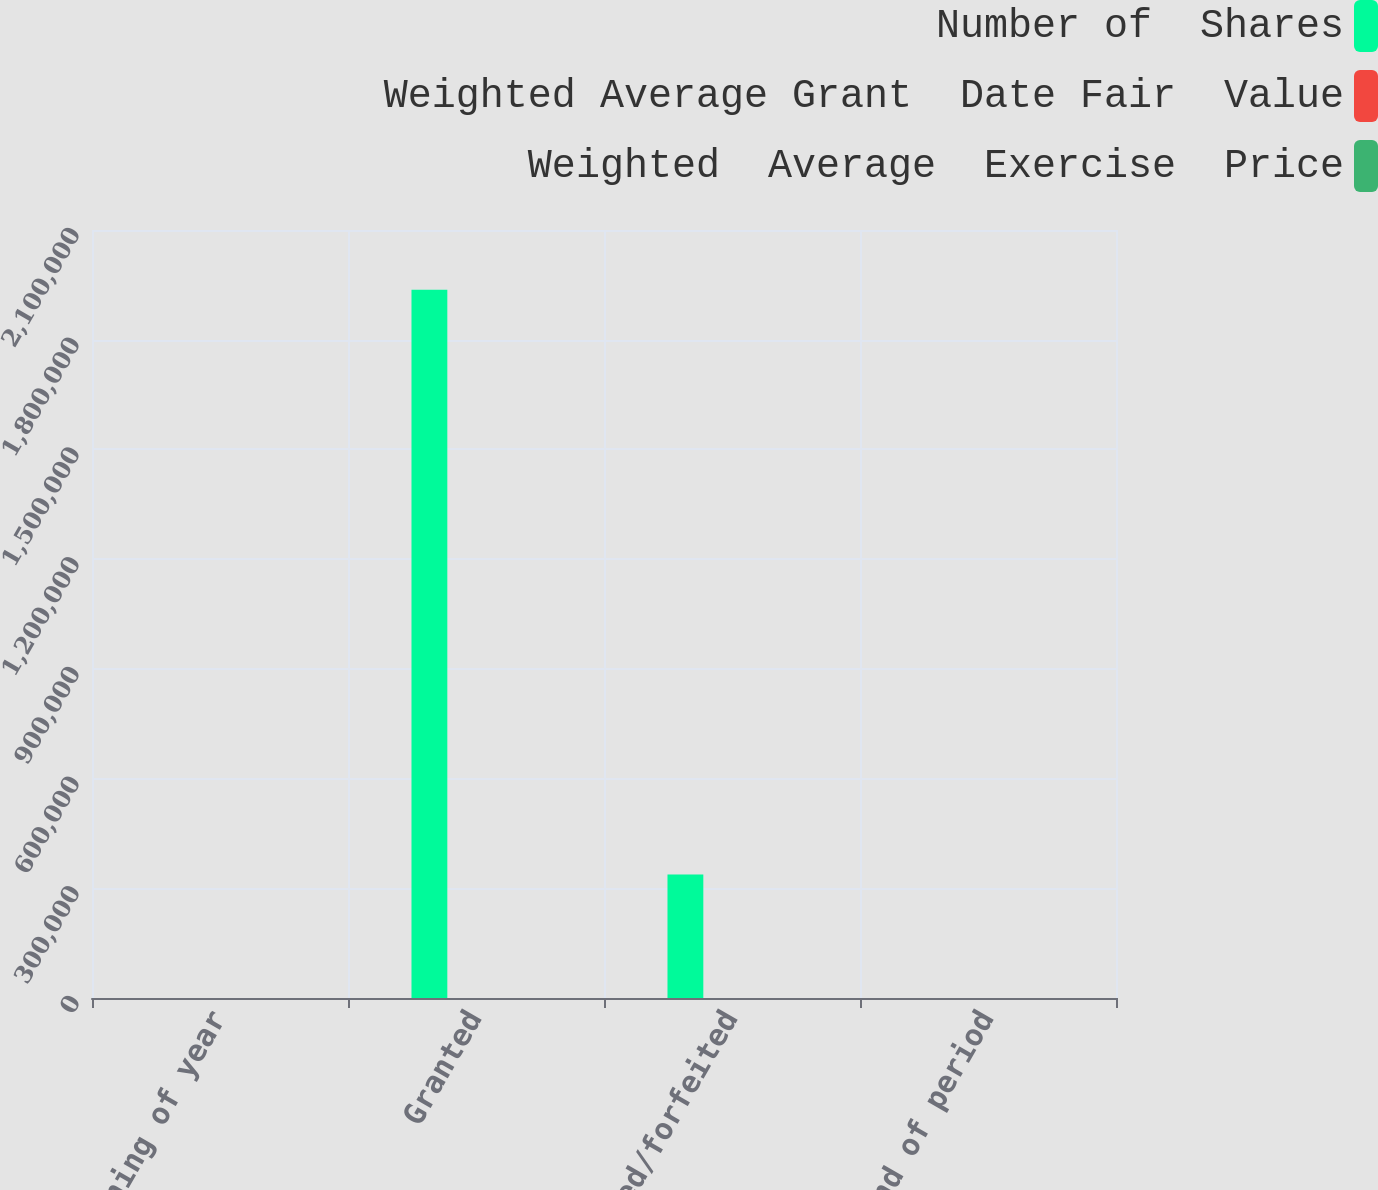Convert chart to OTSL. <chart><loc_0><loc_0><loc_500><loc_500><stacked_bar_chart><ecel><fcel>Beginning of year<fcel>Granted<fcel>Canceled/forfeited<fcel>End of period<nl><fcel>Number of  Shares<fcel>20.175<fcel>1.9367e+06<fcel>337604<fcel>20.175<nl><fcel>Weighted Average Grant  Date Fair  Value<fcel>18.96<fcel>25.23<fcel>22.99<fcel>21.39<nl><fcel>Weighted  Average  Exercise  Price<fcel>5.64<fcel>6.84<fcel>5.93<fcel>6.13<nl></chart> 